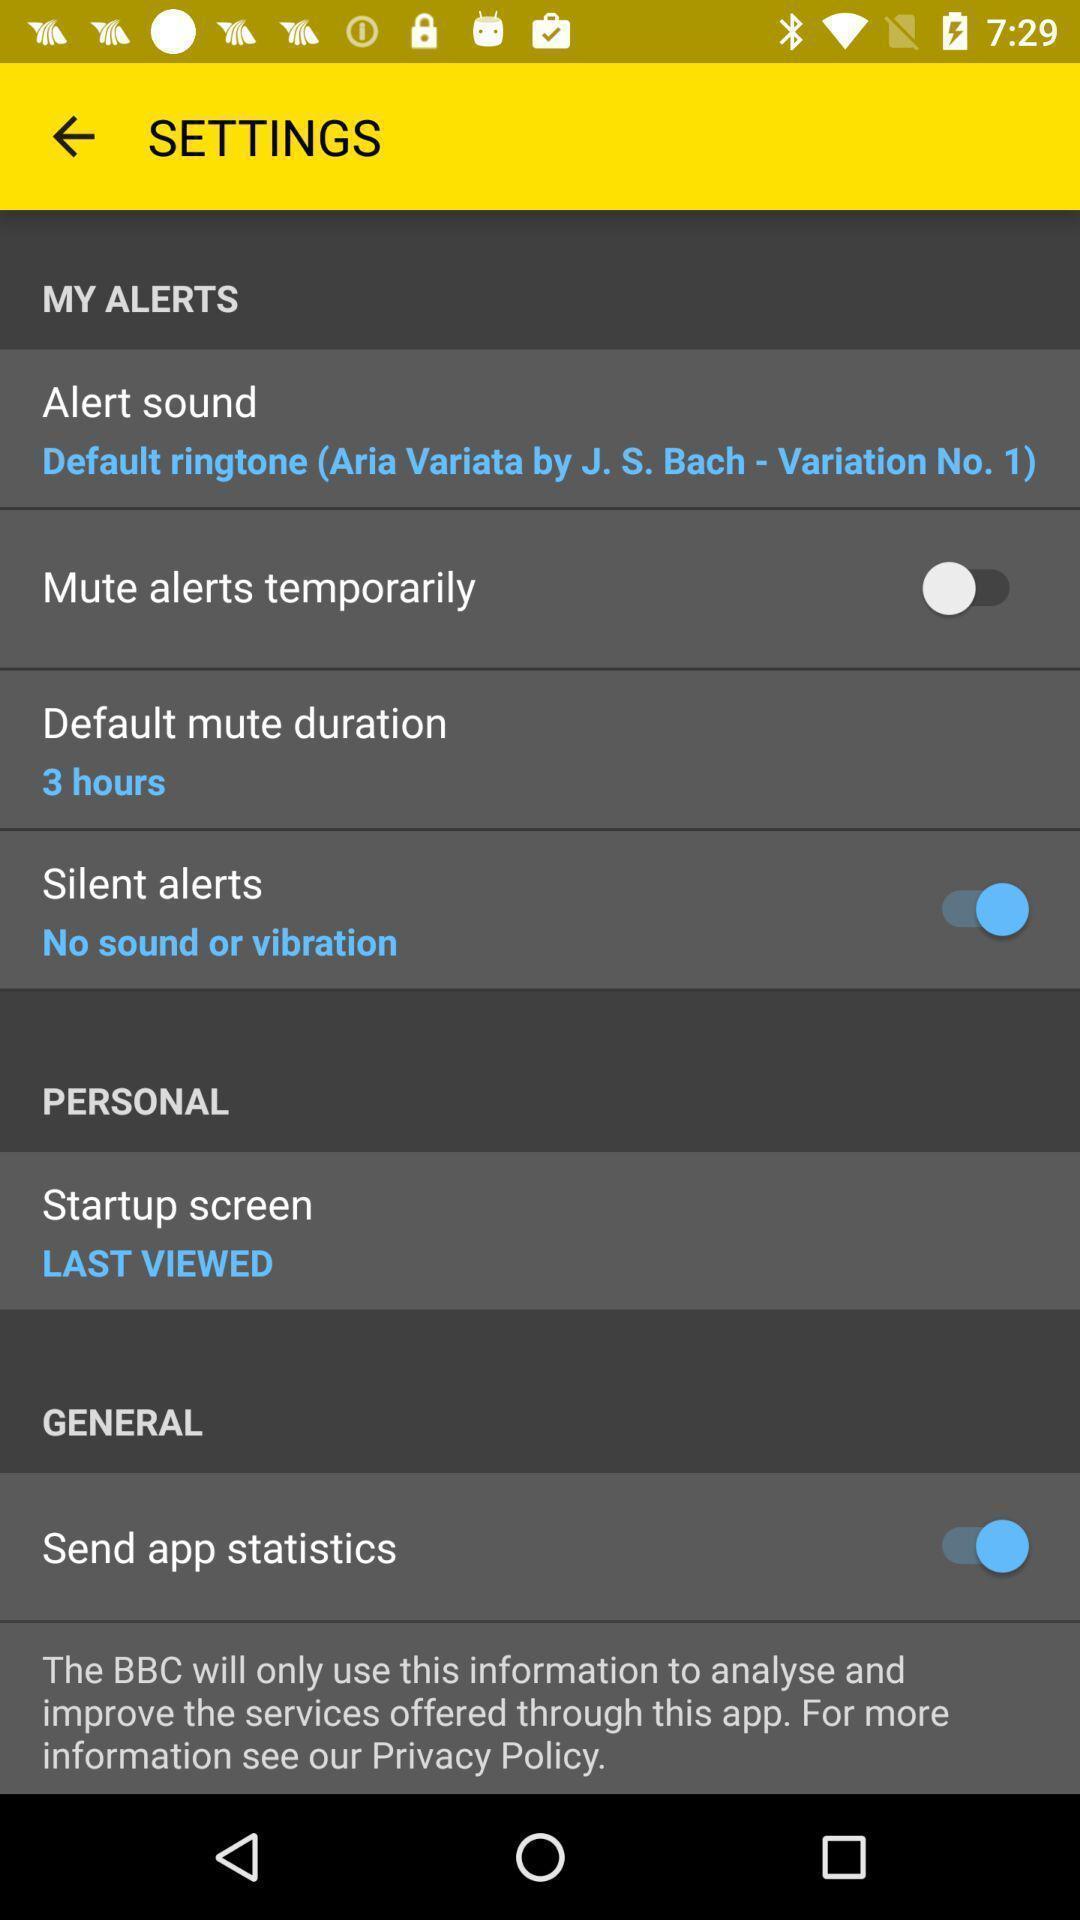Give me a summary of this screen capture. Settings page. 